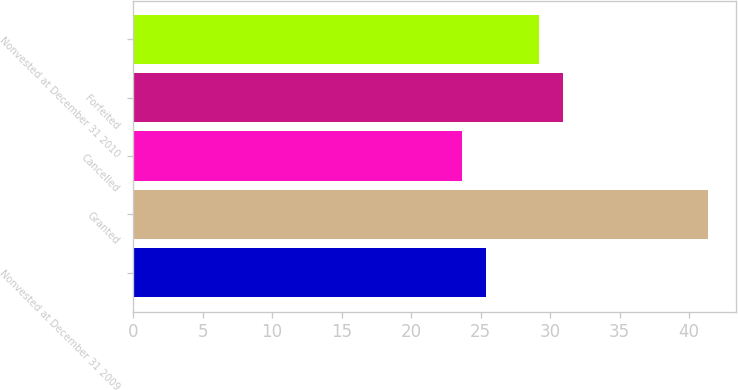Convert chart. <chart><loc_0><loc_0><loc_500><loc_500><bar_chart><fcel>Nonvested at December 31 2009<fcel>Granted<fcel>Cancelled<fcel>Forfeited<fcel>Nonvested at December 31 2010<nl><fcel>25.4<fcel>41.34<fcel>23.63<fcel>30.96<fcel>29.19<nl></chart> 